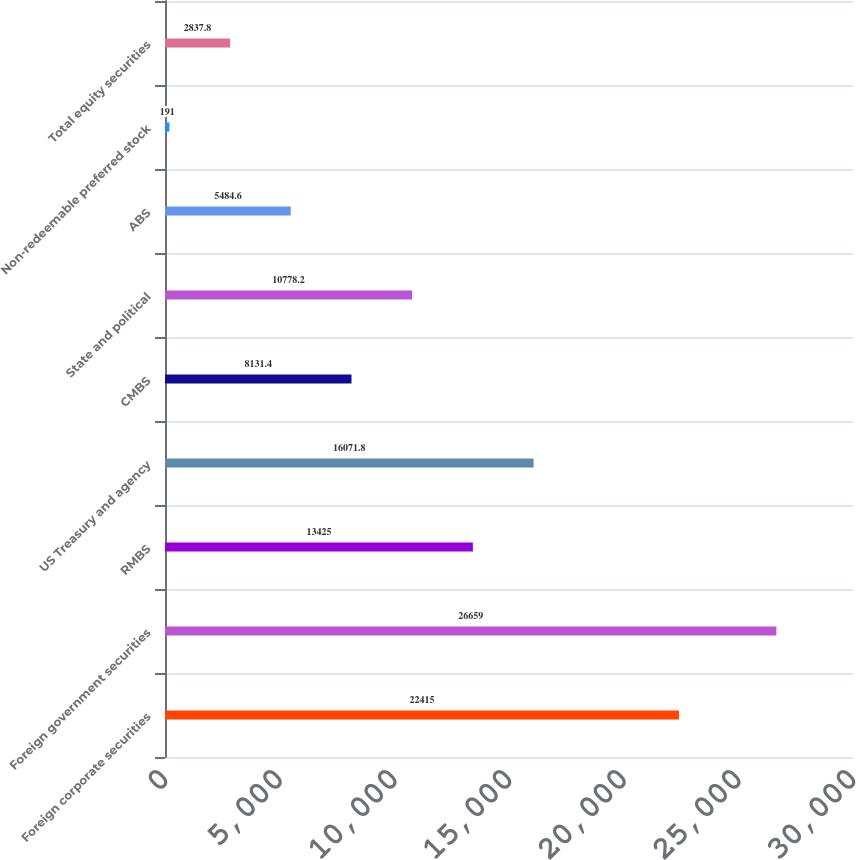Convert chart. <chart><loc_0><loc_0><loc_500><loc_500><bar_chart><fcel>Foreign corporate securities<fcel>Foreign government securities<fcel>RMBS<fcel>US Treasury and agency<fcel>CMBS<fcel>State and political<fcel>ABS<fcel>Non-redeemable preferred stock<fcel>Total equity securities<nl><fcel>22415<fcel>26659<fcel>13425<fcel>16071.8<fcel>8131.4<fcel>10778.2<fcel>5484.6<fcel>191<fcel>2837.8<nl></chart> 